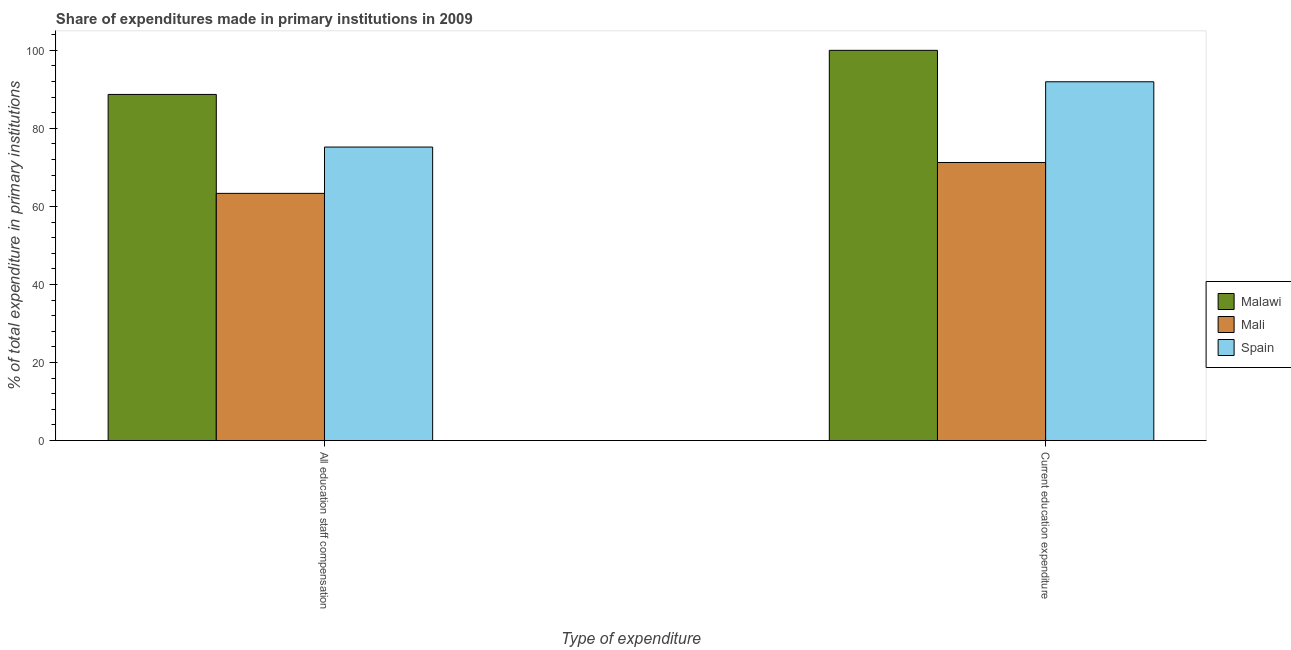How many groups of bars are there?
Your answer should be compact. 2. What is the label of the 2nd group of bars from the left?
Offer a terse response. Current education expenditure. What is the expenditure in education in Mali?
Give a very brief answer. 71.26. Across all countries, what is the maximum expenditure in education?
Your response must be concise. 100. Across all countries, what is the minimum expenditure in education?
Provide a short and direct response. 71.26. In which country was the expenditure in staff compensation maximum?
Offer a terse response. Malawi. In which country was the expenditure in education minimum?
Provide a short and direct response. Mali. What is the total expenditure in education in the graph?
Keep it short and to the point. 263.2. What is the difference between the expenditure in education in Malawi and that in Mali?
Make the answer very short. 28.74. What is the difference between the expenditure in education in Malawi and the expenditure in staff compensation in Mali?
Provide a succinct answer. 36.65. What is the average expenditure in education per country?
Your answer should be very brief. 87.73. What is the difference between the expenditure in staff compensation and expenditure in education in Malawi?
Ensure brevity in your answer.  -11.3. What is the ratio of the expenditure in staff compensation in Malawi to that in Spain?
Keep it short and to the point. 1.18. In how many countries, is the expenditure in staff compensation greater than the average expenditure in staff compensation taken over all countries?
Your answer should be very brief. 1. What does the 3rd bar from the right in All education staff compensation represents?
Make the answer very short. Malawi. How many bars are there?
Offer a terse response. 6. How many countries are there in the graph?
Ensure brevity in your answer.  3. Does the graph contain any zero values?
Provide a short and direct response. No. Where does the legend appear in the graph?
Give a very brief answer. Center right. How many legend labels are there?
Make the answer very short. 3. What is the title of the graph?
Provide a succinct answer. Share of expenditures made in primary institutions in 2009. What is the label or title of the X-axis?
Offer a terse response. Type of expenditure. What is the label or title of the Y-axis?
Make the answer very short. % of total expenditure in primary institutions. What is the % of total expenditure in primary institutions of Malawi in All education staff compensation?
Keep it short and to the point. 88.7. What is the % of total expenditure in primary institutions of Mali in All education staff compensation?
Your answer should be very brief. 63.35. What is the % of total expenditure in primary institutions of Spain in All education staff compensation?
Make the answer very short. 75.22. What is the % of total expenditure in primary institutions in Mali in Current education expenditure?
Your answer should be compact. 71.26. What is the % of total expenditure in primary institutions of Spain in Current education expenditure?
Your answer should be very brief. 91.94. Across all Type of expenditure, what is the maximum % of total expenditure in primary institutions in Mali?
Offer a very short reply. 71.26. Across all Type of expenditure, what is the maximum % of total expenditure in primary institutions in Spain?
Your answer should be very brief. 91.94. Across all Type of expenditure, what is the minimum % of total expenditure in primary institutions of Malawi?
Your answer should be very brief. 88.7. Across all Type of expenditure, what is the minimum % of total expenditure in primary institutions of Mali?
Provide a short and direct response. 63.35. Across all Type of expenditure, what is the minimum % of total expenditure in primary institutions in Spain?
Provide a succinct answer. 75.22. What is the total % of total expenditure in primary institutions in Malawi in the graph?
Your answer should be compact. 188.7. What is the total % of total expenditure in primary institutions of Mali in the graph?
Provide a short and direct response. 134.61. What is the total % of total expenditure in primary institutions in Spain in the graph?
Provide a succinct answer. 167.16. What is the difference between the % of total expenditure in primary institutions in Malawi in All education staff compensation and that in Current education expenditure?
Make the answer very short. -11.3. What is the difference between the % of total expenditure in primary institutions of Mali in All education staff compensation and that in Current education expenditure?
Provide a short and direct response. -7.91. What is the difference between the % of total expenditure in primary institutions of Spain in All education staff compensation and that in Current education expenditure?
Make the answer very short. -16.73. What is the difference between the % of total expenditure in primary institutions in Malawi in All education staff compensation and the % of total expenditure in primary institutions in Mali in Current education expenditure?
Keep it short and to the point. 17.44. What is the difference between the % of total expenditure in primary institutions in Malawi in All education staff compensation and the % of total expenditure in primary institutions in Spain in Current education expenditure?
Give a very brief answer. -3.24. What is the difference between the % of total expenditure in primary institutions in Mali in All education staff compensation and the % of total expenditure in primary institutions in Spain in Current education expenditure?
Give a very brief answer. -28.6. What is the average % of total expenditure in primary institutions in Malawi per Type of expenditure?
Provide a short and direct response. 94.35. What is the average % of total expenditure in primary institutions in Mali per Type of expenditure?
Keep it short and to the point. 67.3. What is the average % of total expenditure in primary institutions of Spain per Type of expenditure?
Ensure brevity in your answer.  83.58. What is the difference between the % of total expenditure in primary institutions in Malawi and % of total expenditure in primary institutions in Mali in All education staff compensation?
Provide a succinct answer. 25.35. What is the difference between the % of total expenditure in primary institutions in Malawi and % of total expenditure in primary institutions in Spain in All education staff compensation?
Provide a short and direct response. 13.48. What is the difference between the % of total expenditure in primary institutions in Mali and % of total expenditure in primary institutions in Spain in All education staff compensation?
Your answer should be compact. -11.87. What is the difference between the % of total expenditure in primary institutions in Malawi and % of total expenditure in primary institutions in Mali in Current education expenditure?
Provide a succinct answer. 28.74. What is the difference between the % of total expenditure in primary institutions of Malawi and % of total expenditure in primary institutions of Spain in Current education expenditure?
Ensure brevity in your answer.  8.06. What is the difference between the % of total expenditure in primary institutions in Mali and % of total expenditure in primary institutions in Spain in Current education expenditure?
Give a very brief answer. -20.68. What is the ratio of the % of total expenditure in primary institutions of Malawi in All education staff compensation to that in Current education expenditure?
Your answer should be compact. 0.89. What is the ratio of the % of total expenditure in primary institutions of Spain in All education staff compensation to that in Current education expenditure?
Offer a terse response. 0.82. What is the difference between the highest and the second highest % of total expenditure in primary institutions in Malawi?
Ensure brevity in your answer.  11.3. What is the difference between the highest and the second highest % of total expenditure in primary institutions in Mali?
Ensure brevity in your answer.  7.91. What is the difference between the highest and the second highest % of total expenditure in primary institutions in Spain?
Provide a short and direct response. 16.73. What is the difference between the highest and the lowest % of total expenditure in primary institutions in Malawi?
Your answer should be very brief. 11.3. What is the difference between the highest and the lowest % of total expenditure in primary institutions of Mali?
Make the answer very short. 7.91. What is the difference between the highest and the lowest % of total expenditure in primary institutions in Spain?
Your answer should be compact. 16.73. 